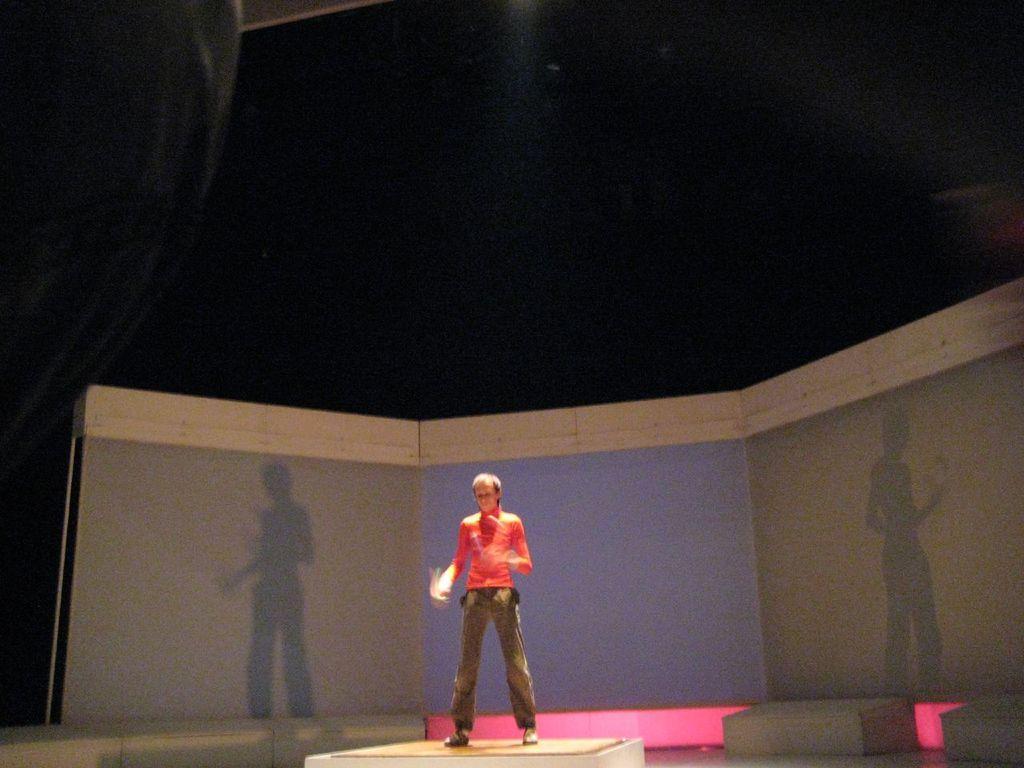Describe this image in one or two sentences. In the image in the center we can see stage. On stage,we can see one person standing and he is wearing orange color t shirt. In the background we can see wall and roof. 